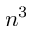<formula> <loc_0><loc_0><loc_500><loc_500>n ^ { 3 }</formula> 